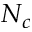Convert formula to latex. <formula><loc_0><loc_0><loc_500><loc_500>N _ { c }</formula> 